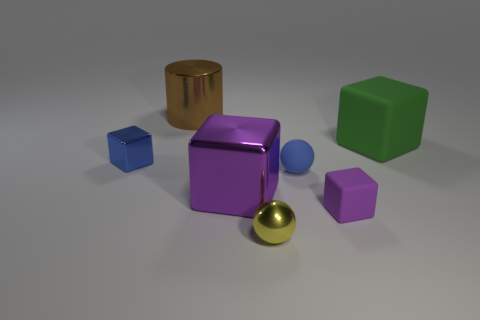Is the material of the blue ball the same as the large purple thing?
Give a very brief answer. No. There is a big purple object that is the same shape as the small purple matte object; what material is it?
Offer a terse response. Metal. Is the small matte sphere the same color as the tiny shiny cube?
Ensure brevity in your answer.  Yes. What number of other objects are the same shape as the small purple object?
Keep it short and to the point. 3. There is a purple thing to the left of the yellow ball; is its size the same as the metal cylinder?
Your answer should be very brief. Yes. Are there more large matte objects that are on the right side of the yellow metal object than small gray objects?
Make the answer very short. Yes. There is a thing that is on the left side of the big brown cylinder; what number of shiny objects are on the right side of it?
Provide a succinct answer. 3. Is the number of yellow balls behind the cylinder less than the number of green spheres?
Give a very brief answer. No. Are there any big things that are on the right side of the blue thing in front of the tiny blue object that is on the left side of the yellow thing?
Provide a short and direct response. Yes. Is the tiny yellow sphere made of the same material as the big object in front of the big green object?
Your response must be concise. Yes. 